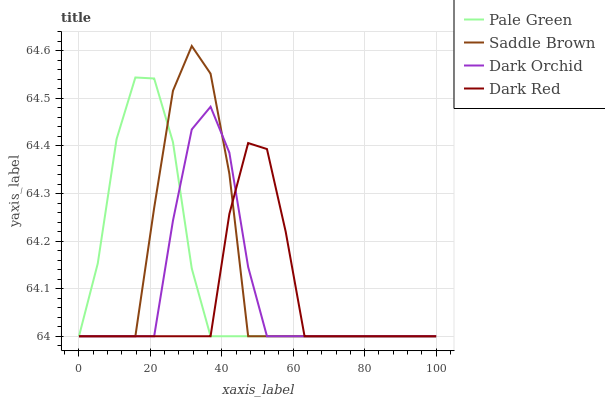Does Pale Green have the minimum area under the curve?
Answer yes or no. No. Does Pale Green have the maximum area under the curve?
Answer yes or no. No. Is Saddle Brown the smoothest?
Answer yes or no. No. Is Pale Green the roughest?
Answer yes or no. No. Does Pale Green have the highest value?
Answer yes or no. No. 